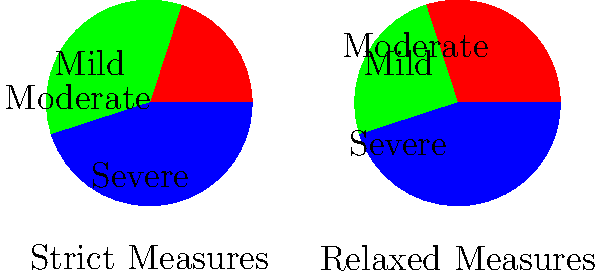The pie charts above represent mental health outcomes in areas with strict and relaxed social distancing measures during a pandemic. Based on this data, what conclusion can be drawn about the effectiveness of strict social distancing measures on mental health outcomes? To analyze the effectiveness of strict social distancing measures on mental health outcomes, we need to compare the two pie charts:

1. Strict Measures:
   - Severe: 20%
   - Moderate: 35%
   - Mild: 45%

2. Relaxed Measures:
   - Severe: 30%
   - Moderate: 25%
   - Mild: 45%

Step 1: Compare severe cases
- Strict measures: 20%
- Relaxed measures: 30%
The percentage of severe cases is lower in areas with strict measures.

Step 2: Compare moderate cases
- Strict measures: 35%
- Relaxed measures: 25%
The percentage of moderate cases is higher in areas with strict measures.

Step 3: Compare mild cases
- Strict measures: 45%
- Relaxed measures: 45%
The percentage of mild cases is the same in both areas.

Step 4: Analyze the overall impact
- Areas with strict measures have fewer severe cases (20% vs. 30%)
- However, they have more moderate cases (35% vs. 25%)
- The percentage of mild cases remains the same (45%)

Step 5: Draw a conclusion
The data suggests that strict social distancing measures may reduce severe mental health outcomes but increase moderate ones. This indicates a potential trade-off between reducing severe cases and increasing moderate cases, while not affecting mild cases.

Given the persona of a professor doubtful of social distancing effectiveness, it's important to note that the data doesn't show a clear overall improvement in mental health outcomes with strict measures. The shift from severe to moderate cases could be interpreted as a modest benefit or as evidence that strict measures don't significantly improve overall mental health outcomes.
Answer: Strict measures reduce severe cases but increase moderate cases, suggesting a limited overall benefit to mental health outcomes. 